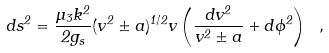<formula> <loc_0><loc_0><loc_500><loc_500>\label l { n e w m o d u l i s p a c e } d s ^ { 2 } = \frac { \mu _ { 3 } k ^ { 2 } } { 2 g _ { s } } ( v ^ { 2 } \pm a ) ^ { 1 / 2 } v \left ( \frac { d v ^ { 2 } } { v ^ { 2 } \pm a } + d \phi ^ { 2 } \right ) \ ,</formula> 